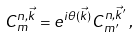<formula> <loc_0><loc_0><loc_500><loc_500>C _ { m } ^ { n , \vec { k } } = e ^ { i \theta ( \vec { k } ) } C _ { m ^ { \prime } } ^ { n , \vec { k } ^ { \prime } } \, ,</formula> 